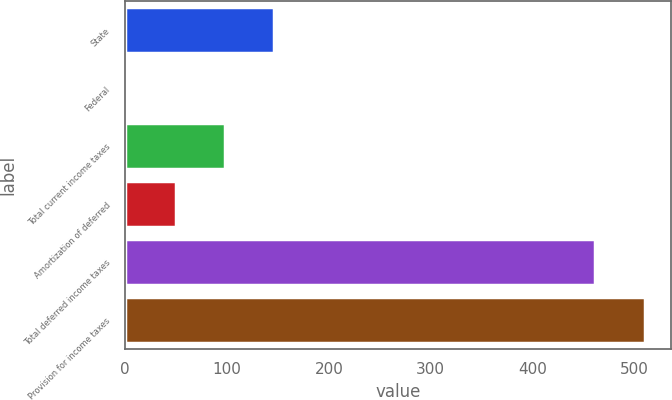<chart> <loc_0><loc_0><loc_500><loc_500><bar_chart><fcel>State<fcel>Federal<fcel>Total current income taxes<fcel>Amortization of deferred<fcel>Total deferred income taxes<fcel>Provision for income taxes<nl><fcel>146.5<fcel>1<fcel>98<fcel>49.5<fcel>462<fcel>510.5<nl></chart> 